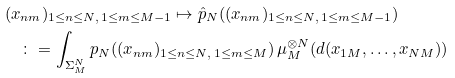Convert formula to latex. <formula><loc_0><loc_0><loc_500><loc_500>& ( x _ { n m } ) _ { 1 \leq n \leq N , \, 1 \leq m \leq M - 1 } \mapsto \hat { p } _ { N } ( ( x _ { n m } ) _ { 1 \leq n \leq N , \, 1 \leq m \leq M - 1 } ) \\ & \quad \colon = \int _ { \Sigma _ { M } ^ { N } } p _ { N } ( ( x _ { n m } ) _ { 1 \leq n \leq N , \, 1 \leq m \leq M } ) \, \mu _ { M } ^ { \otimes N } ( d ( x _ { 1 M } , \dots , x _ { N M } ) ) \\</formula> 